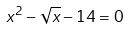Convert formula to latex. <formula><loc_0><loc_0><loc_500><loc_500>x ^ { 2 } - \sqrt { x } - 1 4 = 0</formula> 